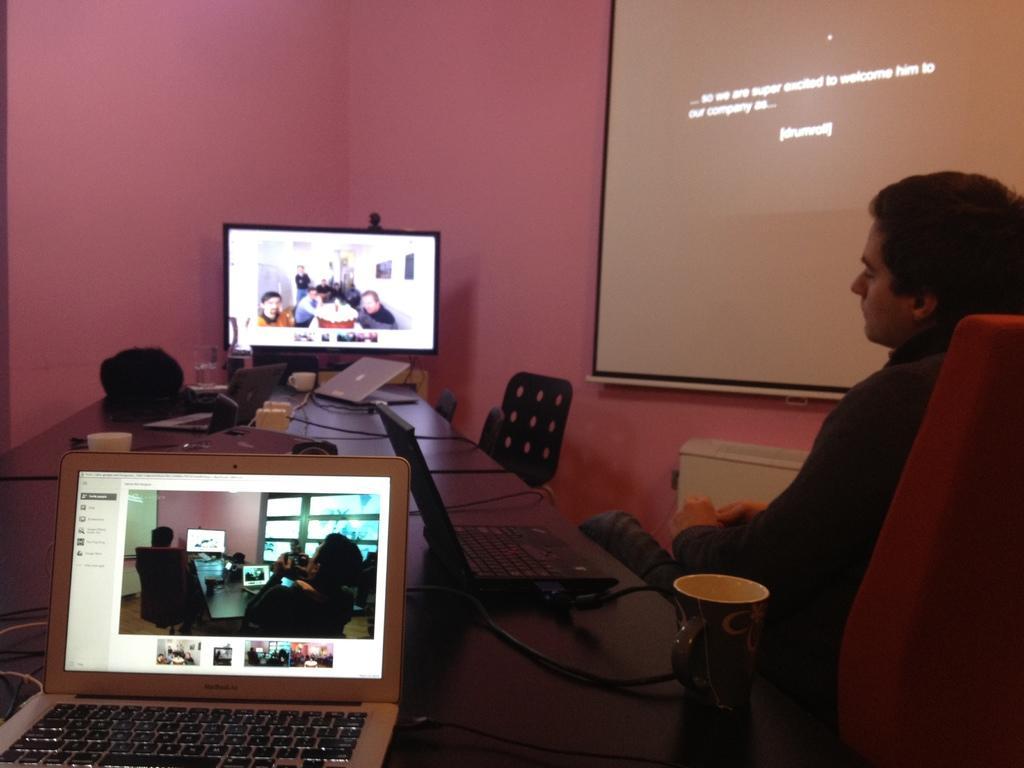Can you describe this image briefly? Bottom right side of the image a man is sitting on a chair. Top right side of the image there is a screen. Top left side of the image there is a wall. Bottom left side of the image there is a table, On the table there is a laptop. In the middle of the image there is a screen. 